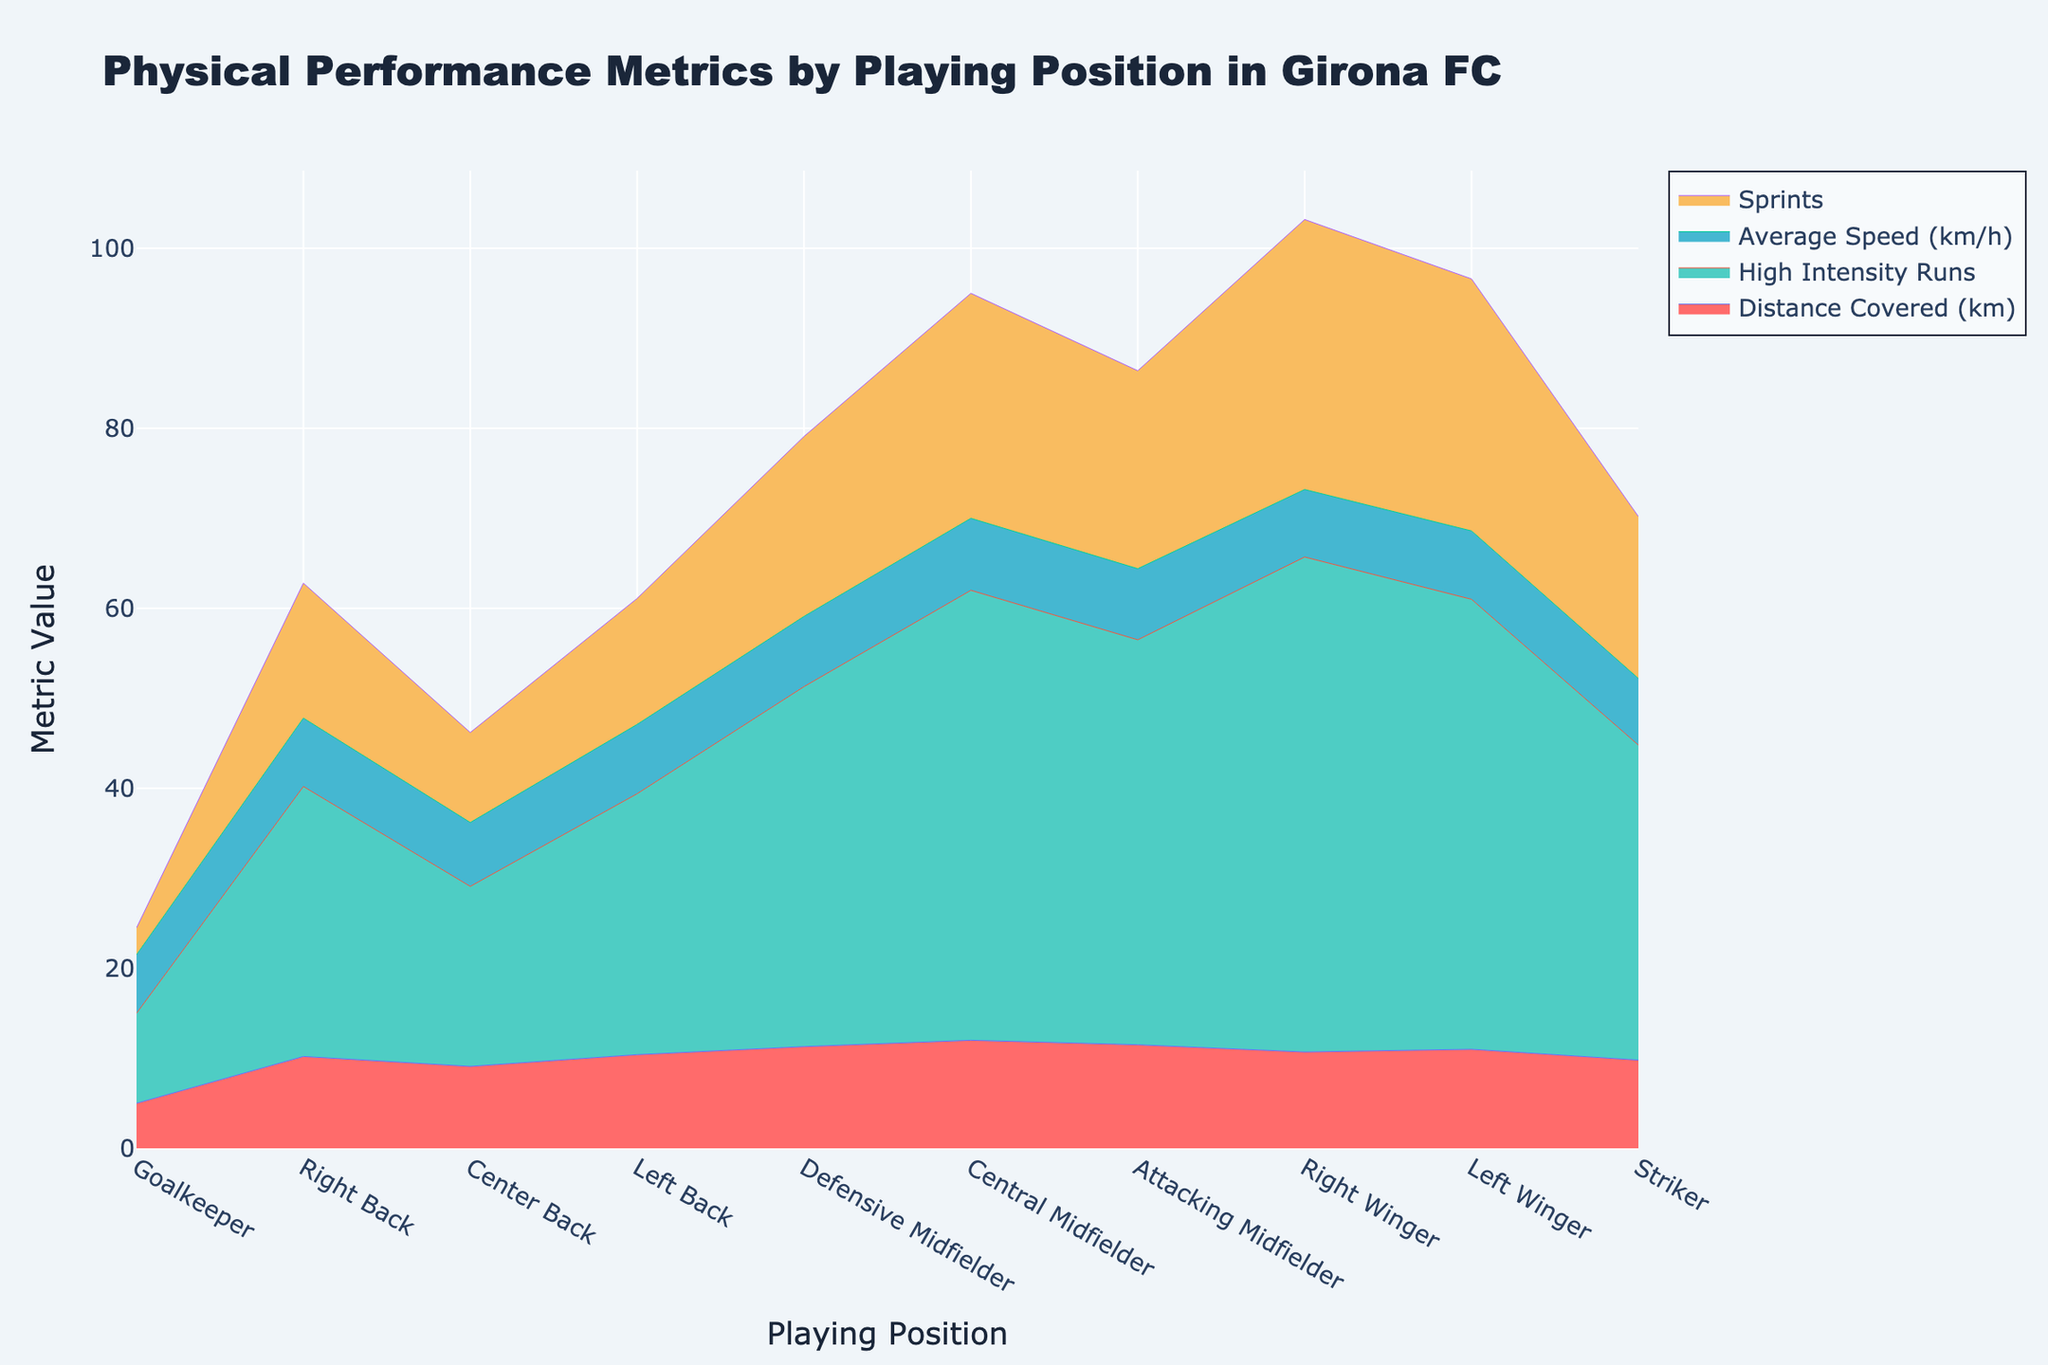What's the title of the figure? The title is usually at the top of the figure. By looking at the top of this figure, we see the title clearly stated.
Answer: Physical Performance Metrics by Playing Position in Girona FC Which position has the highest number of sprints? In the Stream graph, the Sprints metric is shown, and the highest value can be identified. The Right Winger clearly has the highest number of sprints.
Answer: Right Winger How many metrics are visualized in this figure? By observing the legend or the labels in the figure, one can count the various metrics visualized. There are four distinct metrics displayed.
Answer: Four Which position has the lowest average speed? By examining the Average Speed (km/h) line across all positions, it is clear that the Goalkeeper has the lowest average speed.
Answer: Goalkeeper What's the combined distance covered by the Right Back and Left Back positions? From the graph, the distance covered by the Right Back is 10.2 km and by the Left Back is 10.4 km. Adding these gives: 10.2 + 10.4 = 20.6 km.
Answer: 20.6 km Which position has more high-intensity runs: the Central Midfielder or the Right Winger? By comparing the High Intensity Runs metric for both positions, we see that the Right Winger has 55 runs, while the Central Midfielder has 50 runs.
Answer: Right Winger Is the distance covered by Central Midfielders higher than that of Defensive Midfielders? Looking at the Stream graph, the distance covered by the Central Midfielders is 12.0 km, whereas that of Defensive Midfielders is 11.3 km.
Answer: Yes Which position shows the least variation in its physical performance metrics? Least variation can be interpreted as the most flat or even area in the graph across all metrics. The Goalkeeper's metric lines are relatively more stable and show less variation compared to other positions.
Answer: Goalkeeper If you sum up the high-intensity runs of the two midfielder positions (Defensive and Central), what is the total? The Defensive Midfielder has 40 runs and the Central Midfielder has 50 runs. Adding these: 40 + 50 = 90 runs.
Answer: 90 runs 